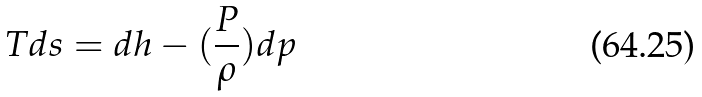Convert formula to latex. <formula><loc_0><loc_0><loc_500><loc_500>T d s = d h - ( \frac { P } { \rho } ) d p</formula> 